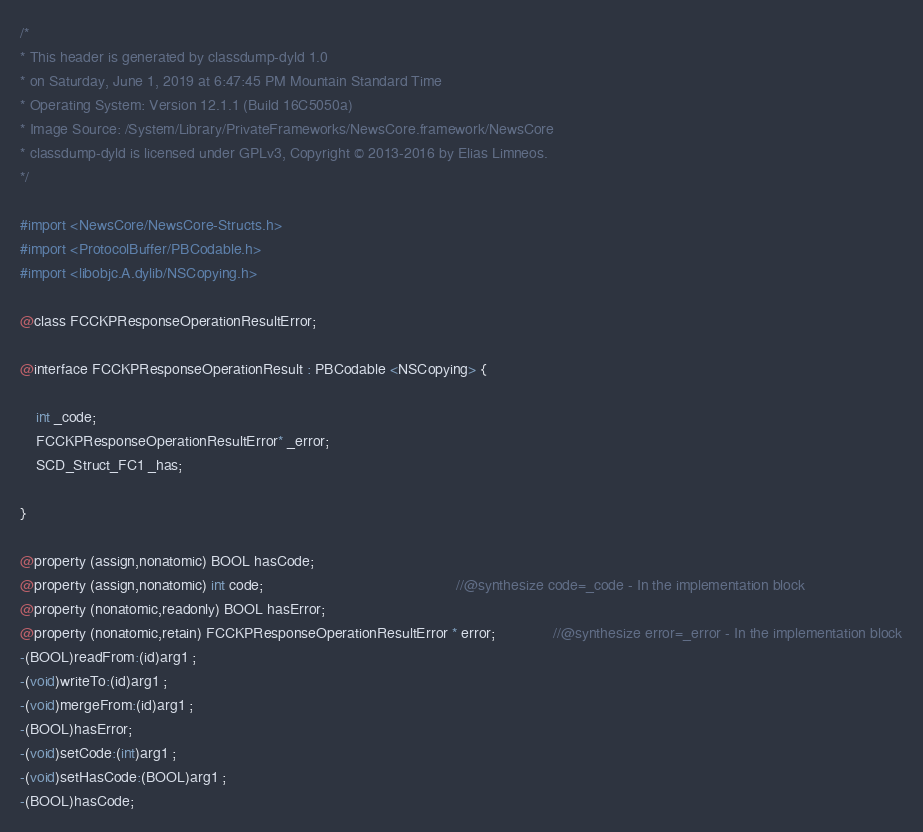<code> <loc_0><loc_0><loc_500><loc_500><_C_>/*
* This header is generated by classdump-dyld 1.0
* on Saturday, June 1, 2019 at 6:47:45 PM Mountain Standard Time
* Operating System: Version 12.1.1 (Build 16C5050a)
* Image Source: /System/Library/PrivateFrameworks/NewsCore.framework/NewsCore
* classdump-dyld is licensed under GPLv3, Copyright © 2013-2016 by Elias Limneos.
*/

#import <NewsCore/NewsCore-Structs.h>
#import <ProtocolBuffer/PBCodable.h>
#import <libobjc.A.dylib/NSCopying.h>

@class FCCKPResponseOperationResultError;

@interface FCCKPResponseOperationResult : PBCodable <NSCopying> {

	int _code;
	FCCKPResponseOperationResultError* _error;
	SCD_Struct_FC1 _has;

}

@property (assign,nonatomic) BOOL hasCode; 
@property (assign,nonatomic) int code;                                               //@synthesize code=_code - In the implementation block
@property (nonatomic,readonly) BOOL hasError; 
@property (nonatomic,retain) FCCKPResponseOperationResultError * error;              //@synthesize error=_error - In the implementation block
-(BOOL)readFrom:(id)arg1 ;
-(void)writeTo:(id)arg1 ;
-(void)mergeFrom:(id)arg1 ;
-(BOOL)hasError;
-(void)setCode:(int)arg1 ;
-(void)setHasCode:(BOOL)arg1 ;
-(BOOL)hasCode;</code> 